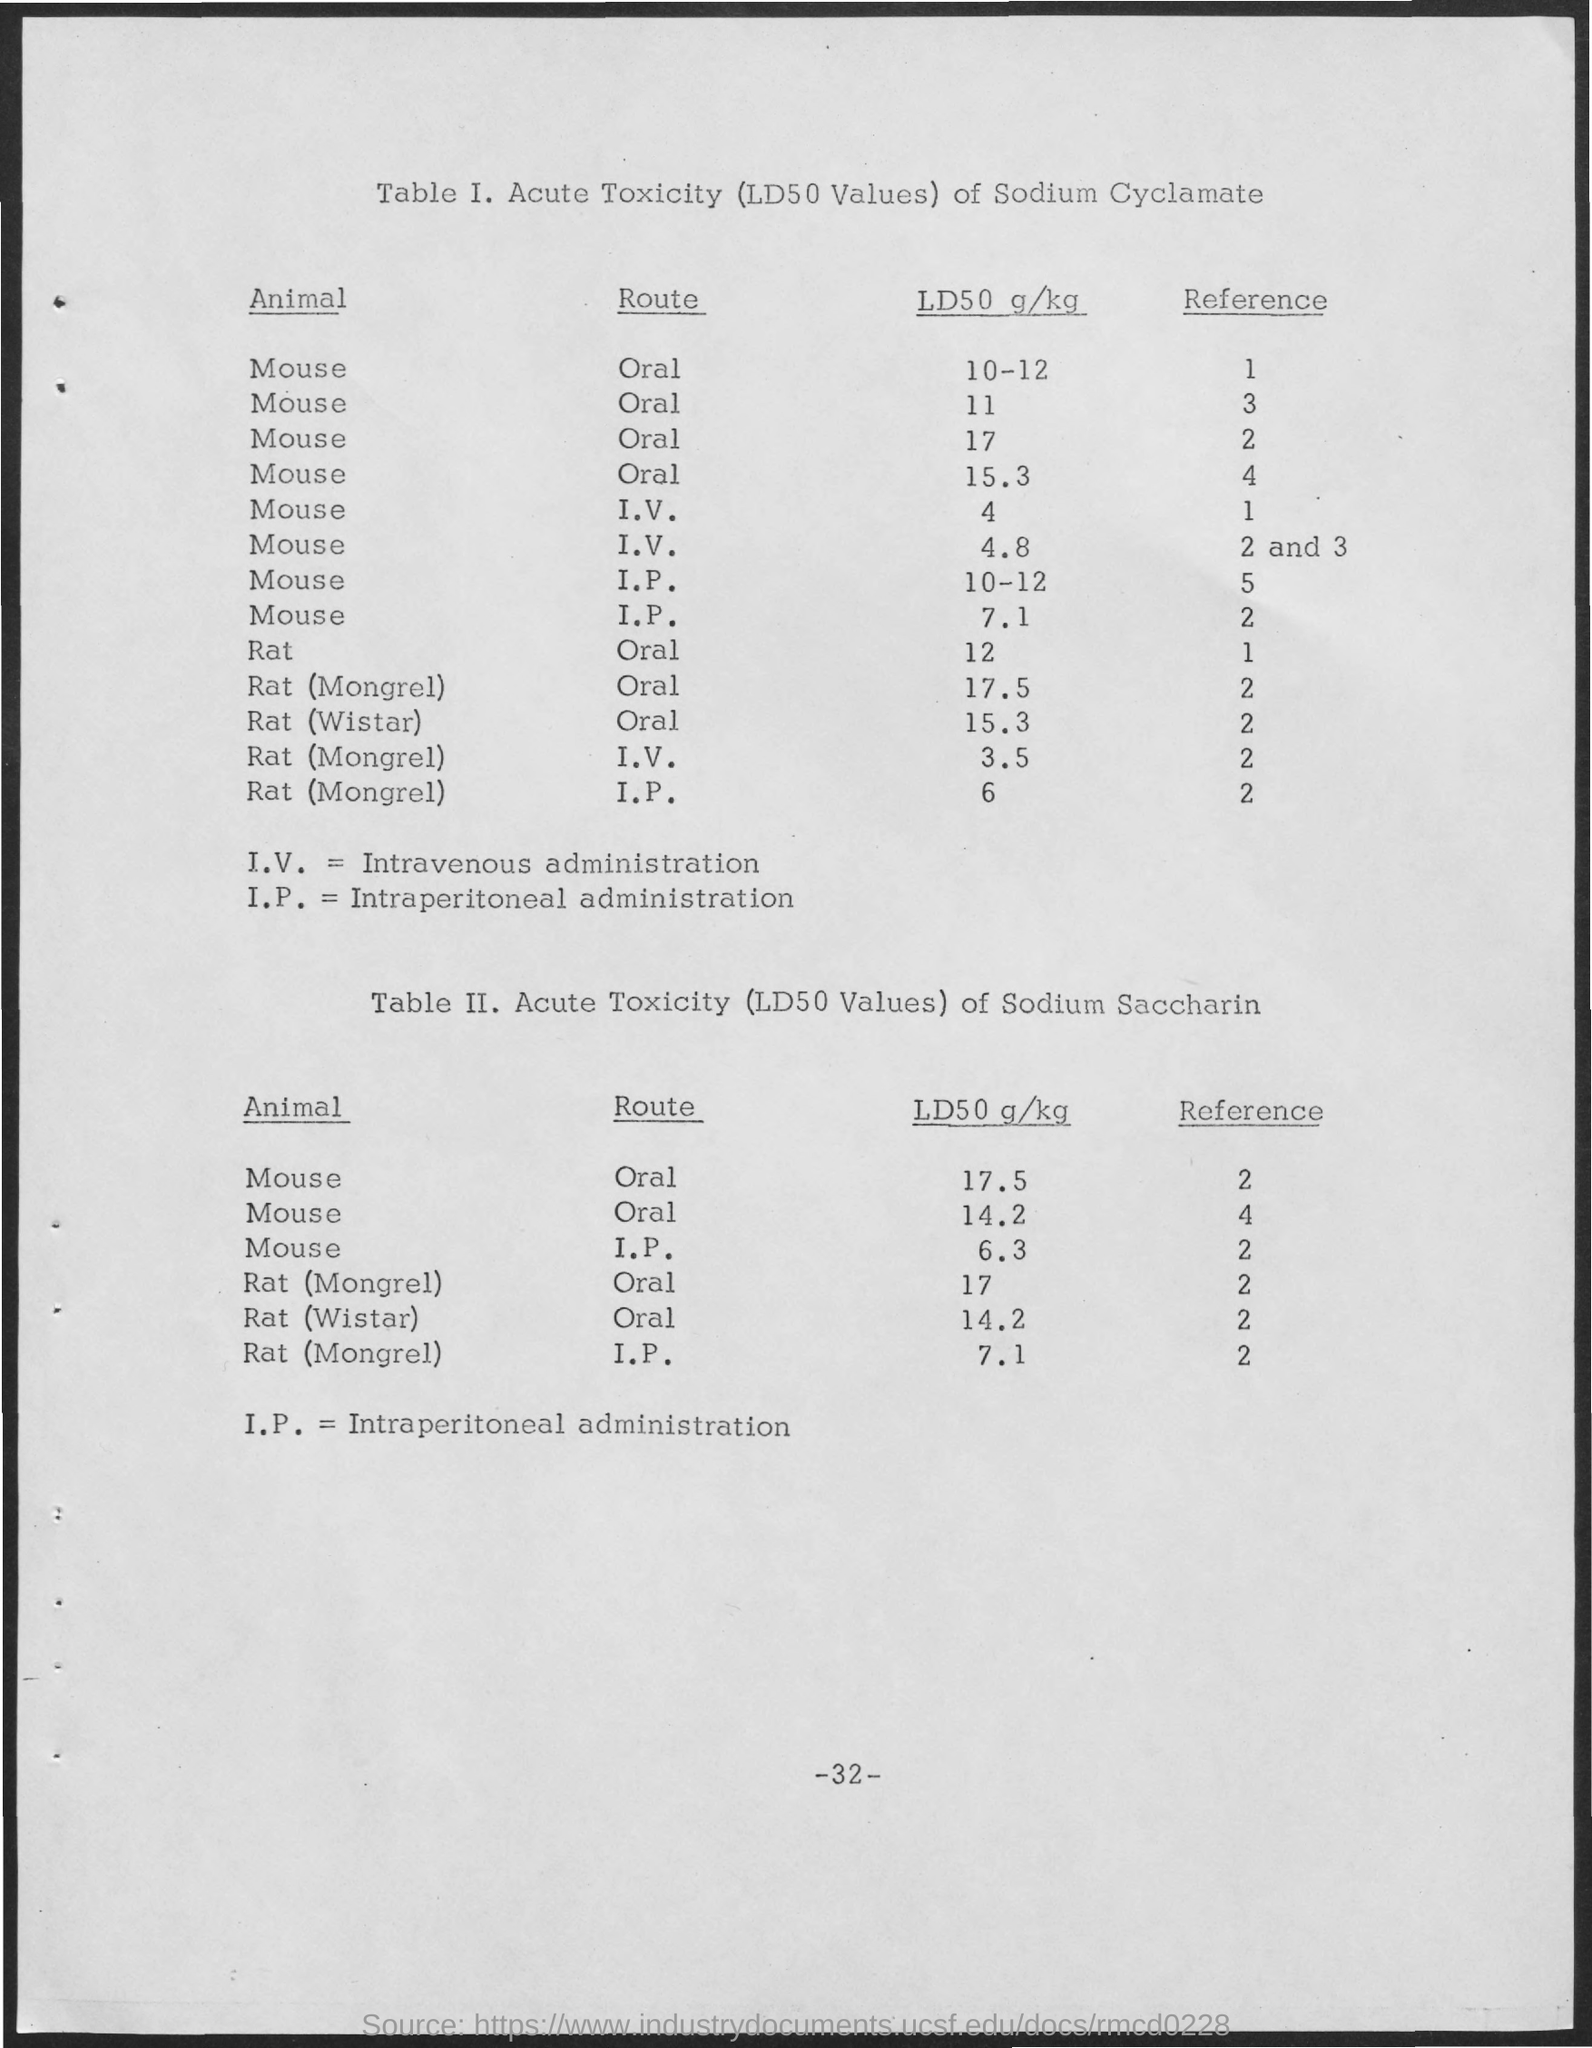What is the full form of I.V ?
Provide a short and direct response. Intravenous administration. What is the full form of I.P ?
Your answer should be compact. Intraperitoneal administration. 